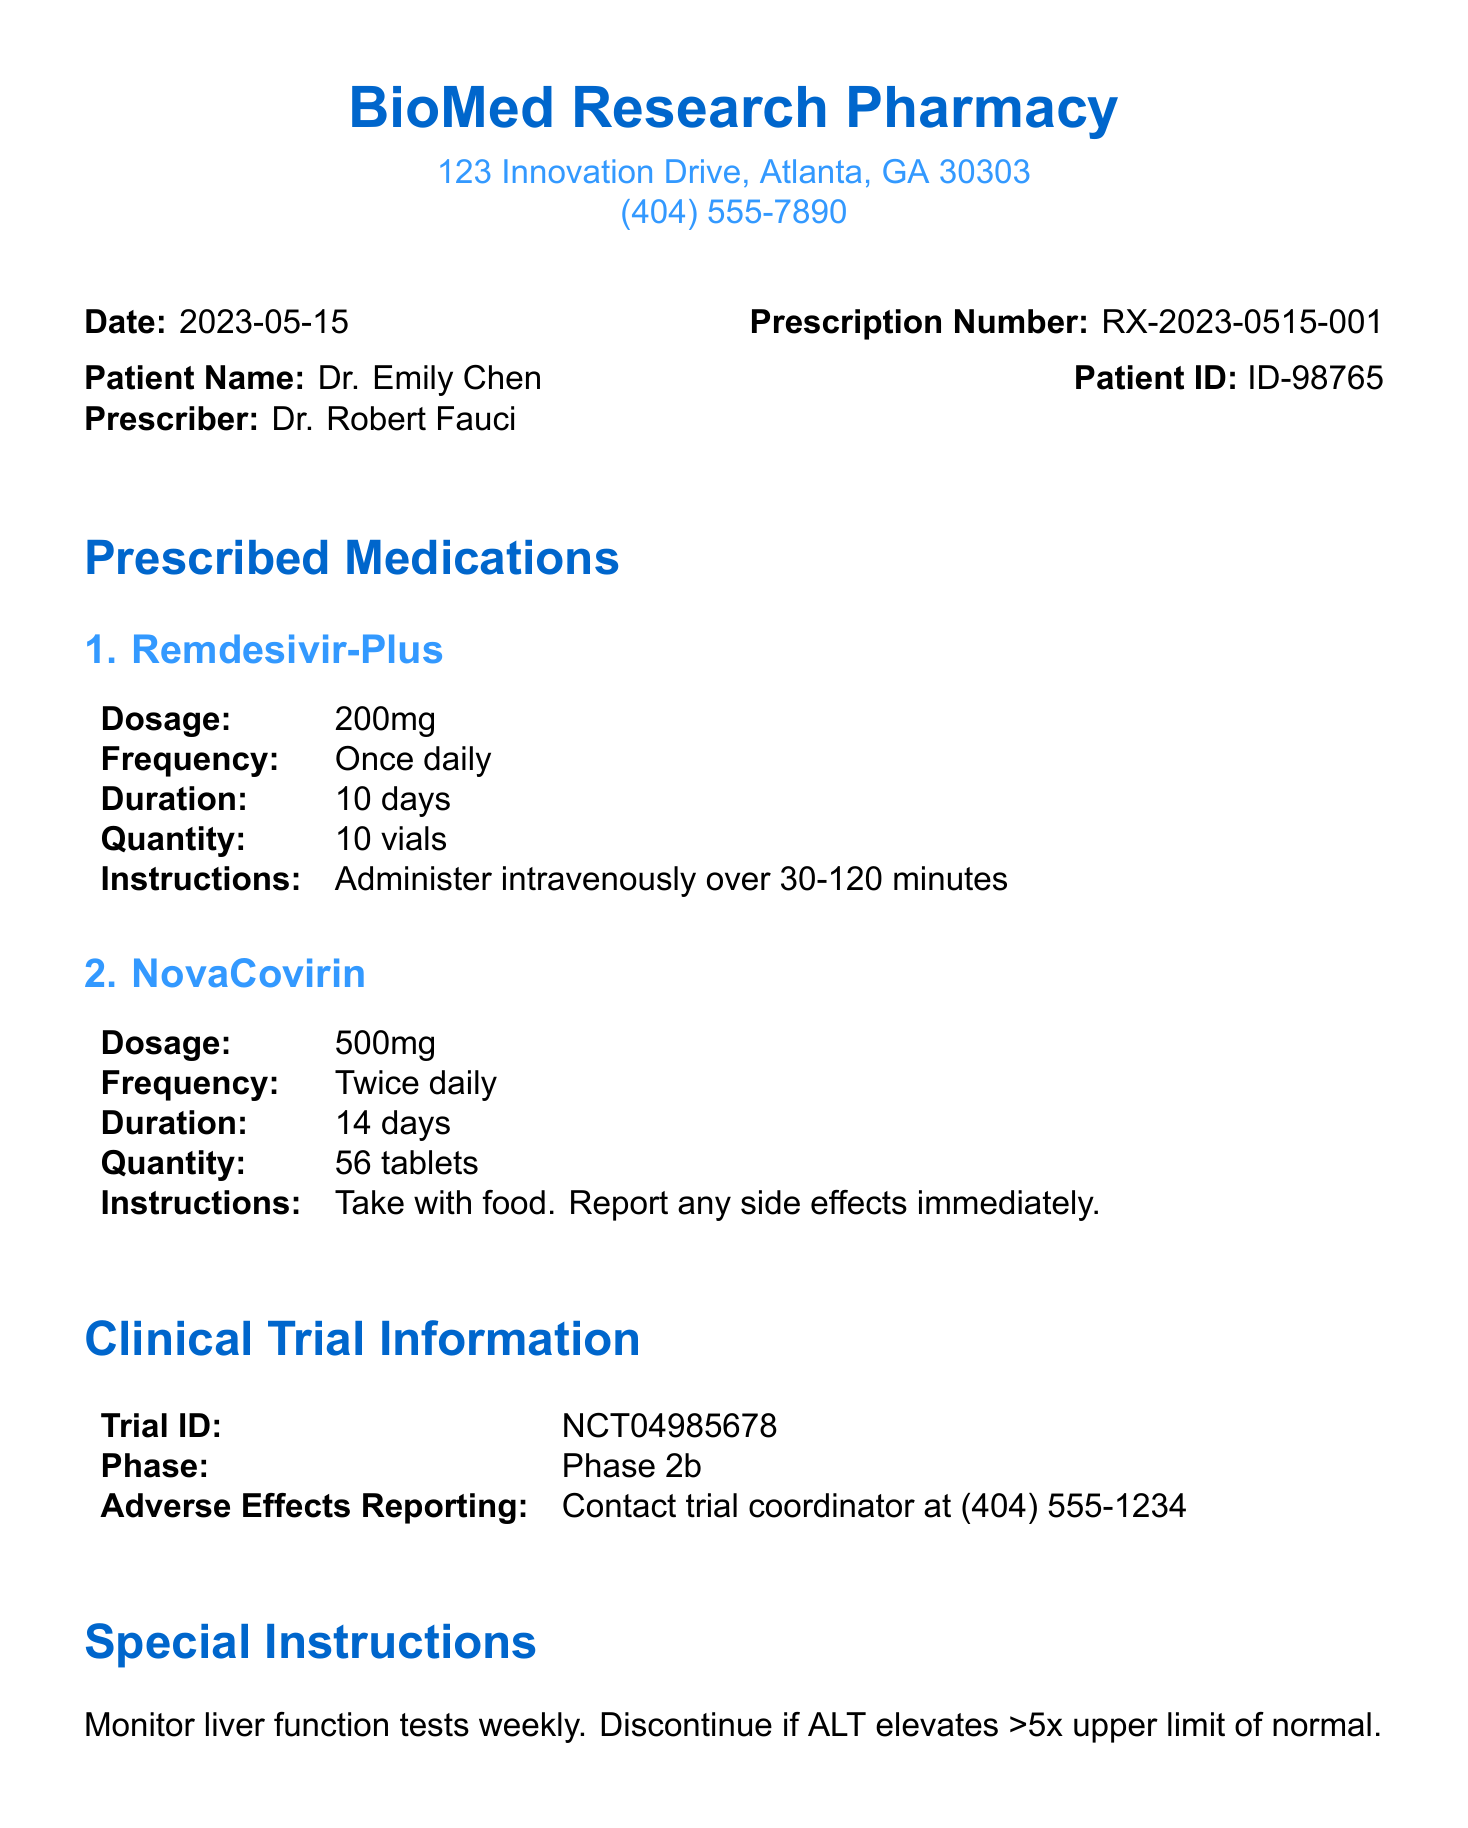What is the pharmacy name? The pharmacy name is clearly stated at the beginning of the document.
Answer: BioMed Research Pharmacy What is Dr. Emily Chen's patient ID? The document specifies the patient ID corresponding to Dr. Emily Chen.
Answer: ID-98765 What is the dosage of Remdesivir-Plus? The dosage for Remdesivir-Plus is directly mentioned in the prescribed medications section.
Answer: 200mg How many tablets of NovaCovirin were prescribed? The quantity prescribed for NovaCovirin is specified in the medications section.
Answer: 56 tablets What is the follow-up appointment date? The follow-up appointment date is provided in the additional information section.
Answer: 2023-05-29 Which trial phase is mentioned in the document? The phase of the clinical trial is indicated in the clinical trial information section.
Answer: Phase 2b Who is the prescriber of the medications? The prescriber's name is explicitly stated in the patient information area.
Answer: Dr. Robert Fauci What special instruction is provided regarding liver function? Special instructions related to liver function monitoring are noted in that section of the document.
Answer: Monitor liver function tests weekly What should be done if side effects occur while taking NovaCovirin? The instructions on side effects are mentioned in relation to NovaCovirin.
Answer: Report any side effects immediately 